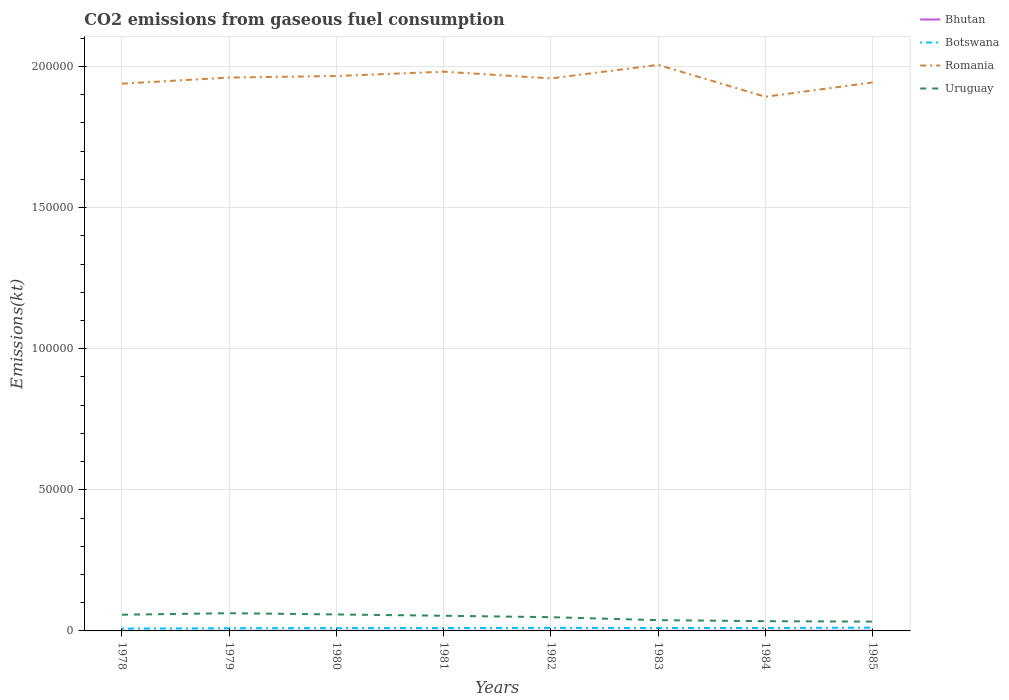How many different coloured lines are there?
Give a very brief answer. 4. Is the number of lines equal to the number of legend labels?
Your answer should be very brief. Yes. Across all years, what is the maximum amount of CO2 emitted in Uruguay?
Your response must be concise. 3296.63. What is the total amount of CO2 emitted in Romania in the graph?
Give a very brief answer. -542.72. What is the difference between the highest and the second highest amount of CO2 emitted in Botswana?
Offer a terse response. 326.36. How many lines are there?
Your answer should be very brief. 4. How many years are there in the graph?
Your answer should be compact. 8. Are the values on the major ticks of Y-axis written in scientific E-notation?
Keep it short and to the point. No. Does the graph contain grids?
Ensure brevity in your answer.  Yes. How many legend labels are there?
Offer a terse response. 4. What is the title of the graph?
Offer a terse response. CO2 emissions from gaseous fuel consumption. Does "Estonia" appear as one of the legend labels in the graph?
Provide a short and direct response. No. What is the label or title of the X-axis?
Keep it short and to the point. Years. What is the label or title of the Y-axis?
Keep it short and to the point. Emissions(kt). What is the Emissions(kt) of Bhutan in 1978?
Provide a short and direct response. 11. What is the Emissions(kt) of Botswana in 1978?
Your answer should be very brief. 832.41. What is the Emissions(kt) of Romania in 1978?
Provide a short and direct response. 1.94e+05. What is the Emissions(kt) in Uruguay in 1978?
Ensure brevity in your answer.  5742.52. What is the Emissions(kt) of Bhutan in 1979?
Offer a terse response. 22. What is the Emissions(kt) of Botswana in 1979?
Provide a short and direct response. 942.42. What is the Emissions(kt) in Romania in 1979?
Your response must be concise. 1.96e+05. What is the Emissions(kt) of Uruguay in 1979?
Your answer should be very brief. 6277.9. What is the Emissions(kt) of Bhutan in 1980?
Provide a succinct answer. 22. What is the Emissions(kt) of Botswana in 1980?
Your answer should be compact. 986.42. What is the Emissions(kt) in Romania in 1980?
Keep it short and to the point. 1.97e+05. What is the Emissions(kt) in Uruguay in 1980?
Offer a terse response. 5837.86. What is the Emissions(kt) in Bhutan in 1981?
Offer a terse response. 25.67. What is the Emissions(kt) in Botswana in 1981?
Provide a succinct answer. 1008.42. What is the Emissions(kt) in Romania in 1981?
Keep it short and to the point. 1.98e+05. What is the Emissions(kt) in Uruguay in 1981?
Your response must be concise. 5375.82. What is the Emissions(kt) in Bhutan in 1982?
Give a very brief answer. 33. What is the Emissions(kt) in Botswana in 1982?
Ensure brevity in your answer.  1100.1. What is the Emissions(kt) in Romania in 1982?
Provide a succinct answer. 1.96e+05. What is the Emissions(kt) in Uruguay in 1982?
Keep it short and to the point. 4873.44. What is the Emissions(kt) in Bhutan in 1983?
Offer a very short reply. 29.34. What is the Emissions(kt) of Botswana in 1983?
Provide a short and direct response. 1030.43. What is the Emissions(kt) of Romania in 1983?
Your response must be concise. 2.01e+05. What is the Emissions(kt) in Uruguay in 1983?
Provide a succinct answer. 3817.35. What is the Emissions(kt) in Bhutan in 1984?
Provide a short and direct response. 51.34. What is the Emissions(kt) of Botswana in 1984?
Provide a short and direct response. 1045.1. What is the Emissions(kt) of Romania in 1984?
Keep it short and to the point. 1.89e+05. What is the Emissions(kt) of Uruguay in 1984?
Provide a short and direct response. 3450.65. What is the Emissions(kt) of Bhutan in 1985?
Provide a short and direct response. 62.34. What is the Emissions(kt) of Botswana in 1985?
Give a very brief answer. 1158.77. What is the Emissions(kt) of Romania in 1985?
Provide a succinct answer. 1.94e+05. What is the Emissions(kt) in Uruguay in 1985?
Ensure brevity in your answer.  3296.63. Across all years, what is the maximum Emissions(kt) in Bhutan?
Provide a short and direct response. 62.34. Across all years, what is the maximum Emissions(kt) of Botswana?
Make the answer very short. 1158.77. Across all years, what is the maximum Emissions(kt) of Romania?
Keep it short and to the point. 2.01e+05. Across all years, what is the maximum Emissions(kt) in Uruguay?
Offer a very short reply. 6277.9. Across all years, what is the minimum Emissions(kt) in Bhutan?
Your response must be concise. 11. Across all years, what is the minimum Emissions(kt) in Botswana?
Your response must be concise. 832.41. Across all years, what is the minimum Emissions(kt) in Romania?
Provide a short and direct response. 1.89e+05. Across all years, what is the minimum Emissions(kt) of Uruguay?
Make the answer very short. 3296.63. What is the total Emissions(kt) in Bhutan in the graph?
Make the answer very short. 256.69. What is the total Emissions(kt) in Botswana in the graph?
Your answer should be compact. 8104.07. What is the total Emissions(kt) in Romania in the graph?
Your answer should be very brief. 1.56e+06. What is the total Emissions(kt) of Uruguay in the graph?
Offer a very short reply. 3.87e+04. What is the difference between the Emissions(kt) of Bhutan in 1978 and that in 1979?
Your answer should be compact. -11. What is the difference between the Emissions(kt) of Botswana in 1978 and that in 1979?
Ensure brevity in your answer.  -110.01. What is the difference between the Emissions(kt) of Romania in 1978 and that in 1979?
Your response must be concise. -2170.86. What is the difference between the Emissions(kt) in Uruguay in 1978 and that in 1979?
Ensure brevity in your answer.  -535.38. What is the difference between the Emissions(kt) in Bhutan in 1978 and that in 1980?
Ensure brevity in your answer.  -11. What is the difference between the Emissions(kt) of Botswana in 1978 and that in 1980?
Provide a short and direct response. -154.01. What is the difference between the Emissions(kt) in Romania in 1978 and that in 1980?
Offer a terse response. -2713.58. What is the difference between the Emissions(kt) in Uruguay in 1978 and that in 1980?
Ensure brevity in your answer.  -95.34. What is the difference between the Emissions(kt) of Bhutan in 1978 and that in 1981?
Offer a very short reply. -14.67. What is the difference between the Emissions(kt) of Botswana in 1978 and that in 1981?
Ensure brevity in your answer.  -176.02. What is the difference between the Emissions(kt) in Romania in 1978 and that in 1981?
Keep it short and to the point. -4250.05. What is the difference between the Emissions(kt) in Uruguay in 1978 and that in 1981?
Provide a succinct answer. 366.7. What is the difference between the Emissions(kt) in Bhutan in 1978 and that in 1982?
Your answer should be very brief. -22. What is the difference between the Emissions(kt) in Botswana in 1978 and that in 1982?
Give a very brief answer. -267.69. What is the difference between the Emissions(kt) in Romania in 1978 and that in 1982?
Offer a very short reply. -1870.17. What is the difference between the Emissions(kt) in Uruguay in 1978 and that in 1982?
Your answer should be compact. 869.08. What is the difference between the Emissions(kt) of Bhutan in 1978 and that in 1983?
Ensure brevity in your answer.  -18.34. What is the difference between the Emissions(kt) in Botswana in 1978 and that in 1983?
Make the answer very short. -198.02. What is the difference between the Emissions(kt) of Romania in 1978 and that in 1983?
Provide a succinct answer. -6659.27. What is the difference between the Emissions(kt) of Uruguay in 1978 and that in 1983?
Offer a terse response. 1925.17. What is the difference between the Emissions(kt) in Bhutan in 1978 and that in 1984?
Offer a terse response. -40.34. What is the difference between the Emissions(kt) of Botswana in 1978 and that in 1984?
Offer a terse response. -212.69. What is the difference between the Emissions(kt) of Romania in 1978 and that in 1984?
Ensure brevity in your answer.  4631.42. What is the difference between the Emissions(kt) in Uruguay in 1978 and that in 1984?
Ensure brevity in your answer.  2291.88. What is the difference between the Emissions(kt) of Bhutan in 1978 and that in 1985?
Your answer should be compact. -51.34. What is the difference between the Emissions(kt) in Botswana in 1978 and that in 1985?
Your answer should be compact. -326.36. What is the difference between the Emissions(kt) in Romania in 1978 and that in 1985?
Provide a succinct answer. -440.04. What is the difference between the Emissions(kt) of Uruguay in 1978 and that in 1985?
Provide a succinct answer. 2445.89. What is the difference between the Emissions(kt) of Botswana in 1979 and that in 1980?
Offer a terse response. -44. What is the difference between the Emissions(kt) of Romania in 1979 and that in 1980?
Your response must be concise. -542.72. What is the difference between the Emissions(kt) in Uruguay in 1979 and that in 1980?
Make the answer very short. 440.04. What is the difference between the Emissions(kt) of Bhutan in 1979 and that in 1981?
Your answer should be compact. -3.67. What is the difference between the Emissions(kt) of Botswana in 1979 and that in 1981?
Make the answer very short. -66.01. What is the difference between the Emissions(kt) in Romania in 1979 and that in 1981?
Ensure brevity in your answer.  -2079.19. What is the difference between the Emissions(kt) of Uruguay in 1979 and that in 1981?
Your answer should be very brief. 902.08. What is the difference between the Emissions(kt) in Bhutan in 1979 and that in 1982?
Provide a short and direct response. -11. What is the difference between the Emissions(kt) of Botswana in 1979 and that in 1982?
Offer a very short reply. -157.68. What is the difference between the Emissions(kt) in Romania in 1979 and that in 1982?
Keep it short and to the point. 300.69. What is the difference between the Emissions(kt) in Uruguay in 1979 and that in 1982?
Make the answer very short. 1404.46. What is the difference between the Emissions(kt) in Bhutan in 1979 and that in 1983?
Ensure brevity in your answer.  -7.33. What is the difference between the Emissions(kt) of Botswana in 1979 and that in 1983?
Provide a short and direct response. -88.01. What is the difference between the Emissions(kt) of Romania in 1979 and that in 1983?
Make the answer very short. -4488.41. What is the difference between the Emissions(kt) in Uruguay in 1979 and that in 1983?
Keep it short and to the point. 2460.56. What is the difference between the Emissions(kt) in Bhutan in 1979 and that in 1984?
Offer a very short reply. -29.34. What is the difference between the Emissions(kt) of Botswana in 1979 and that in 1984?
Your answer should be compact. -102.68. What is the difference between the Emissions(kt) in Romania in 1979 and that in 1984?
Keep it short and to the point. 6802.28. What is the difference between the Emissions(kt) in Uruguay in 1979 and that in 1984?
Provide a succinct answer. 2827.26. What is the difference between the Emissions(kt) of Bhutan in 1979 and that in 1985?
Provide a short and direct response. -40.34. What is the difference between the Emissions(kt) of Botswana in 1979 and that in 1985?
Give a very brief answer. -216.35. What is the difference between the Emissions(kt) in Romania in 1979 and that in 1985?
Provide a succinct answer. 1730.82. What is the difference between the Emissions(kt) of Uruguay in 1979 and that in 1985?
Ensure brevity in your answer.  2981.27. What is the difference between the Emissions(kt) in Bhutan in 1980 and that in 1981?
Your answer should be compact. -3.67. What is the difference between the Emissions(kt) in Botswana in 1980 and that in 1981?
Offer a terse response. -22. What is the difference between the Emissions(kt) of Romania in 1980 and that in 1981?
Your answer should be compact. -1536.47. What is the difference between the Emissions(kt) of Uruguay in 1980 and that in 1981?
Offer a terse response. 462.04. What is the difference between the Emissions(kt) in Bhutan in 1980 and that in 1982?
Your response must be concise. -11. What is the difference between the Emissions(kt) in Botswana in 1980 and that in 1982?
Your answer should be compact. -113.68. What is the difference between the Emissions(kt) of Romania in 1980 and that in 1982?
Your answer should be compact. 843.41. What is the difference between the Emissions(kt) of Uruguay in 1980 and that in 1982?
Provide a succinct answer. 964.42. What is the difference between the Emissions(kt) in Bhutan in 1980 and that in 1983?
Your answer should be compact. -7.33. What is the difference between the Emissions(kt) of Botswana in 1980 and that in 1983?
Make the answer very short. -44. What is the difference between the Emissions(kt) in Romania in 1980 and that in 1983?
Your answer should be very brief. -3945.69. What is the difference between the Emissions(kt) of Uruguay in 1980 and that in 1983?
Provide a succinct answer. 2020.52. What is the difference between the Emissions(kt) in Bhutan in 1980 and that in 1984?
Give a very brief answer. -29.34. What is the difference between the Emissions(kt) of Botswana in 1980 and that in 1984?
Your response must be concise. -58.67. What is the difference between the Emissions(kt) of Romania in 1980 and that in 1984?
Offer a very short reply. 7345. What is the difference between the Emissions(kt) of Uruguay in 1980 and that in 1984?
Keep it short and to the point. 2387.22. What is the difference between the Emissions(kt) in Bhutan in 1980 and that in 1985?
Give a very brief answer. -40.34. What is the difference between the Emissions(kt) in Botswana in 1980 and that in 1985?
Provide a short and direct response. -172.35. What is the difference between the Emissions(kt) in Romania in 1980 and that in 1985?
Ensure brevity in your answer.  2273.54. What is the difference between the Emissions(kt) of Uruguay in 1980 and that in 1985?
Give a very brief answer. 2541.23. What is the difference between the Emissions(kt) of Bhutan in 1981 and that in 1982?
Keep it short and to the point. -7.33. What is the difference between the Emissions(kt) of Botswana in 1981 and that in 1982?
Your answer should be very brief. -91.67. What is the difference between the Emissions(kt) of Romania in 1981 and that in 1982?
Provide a short and direct response. 2379.88. What is the difference between the Emissions(kt) in Uruguay in 1981 and that in 1982?
Your answer should be very brief. 502.38. What is the difference between the Emissions(kt) of Bhutan in 1981 and that in 1983?
Ensure brevity in your answer.  -3.67. What is the difference between the Emissions(kt) in Botswana in 1981 and that in 1983?
Offer a very short reply. -22. What is the difference between the Emissions(kt) of Romania in 1981 and that in 1983?
Make the answer very short. -2409.22. What is the difference between the Emissions(kt) of Uruguay in 1981 and that in 1983?
Provide a succinct answer. 1558.47. What is the difference between the Emissions(kt) of Bhutan in 1981 and that in 1984?
Offer a terse response. -25.67. What is the difference between the Emissions(kt) of Botswana in 1981 and that in 1984?
Provide a succinct answer. -36.67. What is the difference between the Emissions(kt) of Romania in 1981 and that in 1984?
Provide a succinct answer. 8881.47. What is the difference between the Emissions(kt) in Uruguay in 1981 and that in 1984?
Provide a short and direct response. 1925.17. What is the difference between the Emissions(kt) in Bhutan in 1981 and that in 1985?
Offer a terse response. -36.67. What is the difference between the Emissions(kt) in Botswana in 1981 and that in 1985?
Offer a very short reply. -150.35. What is the difference between the Emissions(kt) of Romania in 1981 and that in 1985?
Your answer should be compact. 3810.01. What is the difference between the Emissions(kt) in Uruguay in 1981 and that in 1985?
Give a very brief answer. 2079.19. What is the difference between the Emissions(kt) in Bhutan in 1982 and that in 1983?
Your answer should be compact. 3.67. What is the difference between the Emissions(kt) of Botswana in 1982 and that in 1983?
Your response must be concise. 69.67. What is the difference between the Emissions(kt) of Romania in 1982 and that in 1983?
Ensure brevity in your answer.  -4789.1. What is the difference between the Emissions(kt) in Uruguay in 1982 and that in 1983?
Give a very brief answer. 1056.1. What is the difference between the Emissions(kt) of Bhutan in 1982 and that in 1984?
Make the answer very short. -18.34. What is the difference between the Emissions(kt) of Botswana in 1982 and that in 1984?
Your answer should be very brief. 55.01. What is the difference between the Emissions(kt) in Romania in 1982 and that in 1984?
Your answer should be very brief. 6501.59. What is the difference between the Emissions(kt) of Uruguay in 1982 and that in 1984?
Offer a terse response. 1422.8. What is the difference between the Emissions(kt) in Bhutan in 1982 and that in 1985?
Make the answer very short. -29.34. What is the difference between the Emissions(kt) in Botswana in 1982 and that in 1985?
Provide a succinct answer. -58.67. What is the difference between the Emissions(kt) of Romania in 1982 and that in 1985?
Provide a succinct answer. 1430.13. What is the difference between the Emissions(kt) in Uruguay in 1982 and that in 1985?
Your answer should be very brief. 1576.81. What is the difference between the Emissions(kt) of Bhutan in 1983 and that in 1984?
Provide a short and direct response. -22. What is the difference between the Emissions(kt) of Botswana in 1983 and that in 1984?
Offer a very short reply. -14.67. What is the difference between the Emissions(kt) of Romania in 1983 and that in 1984?
Your response must be concise. 1.13e+04. What is the difference between the Emissions(kt) of Uruguay in 1983 and that in 1984?
Provide a short and direct response. 366.7. What is the difference between the Emissions(kt) in Bhutan in 1983 and that in 1985?
Provide a succinct answer. -33. What is the difference between the Emissions(kt) of Botswana in 1983 and that in 1985?
Offer a very short reply. -128.34. What is the difference between the Emissions(kt) in Romania in 1983 and that in 1985?
Keep it short and to the point. 6219.23. What is the difference between the Emissions(kt) in Uruguay in 1983 and that in 1985?
Provide a short and direct response. 520.71. What is the difference between the Emissions(kt) of Bhutan in 1984 and that in 1985?
Keep it short and to the point. -11. What is the difference between the Emissions(kt) in Botswana in 1984 and that in 1985?
Your answer should be compact. -113.68. What is the difference between the Emissions(kt) of Romania in 1984 and that in 1985?
Keep it short and to the point. -5071.46. What is the difference between the Emissions(kt) in Uruguay in 1984 and that in 1985?
Keep it short and to the point. 154.01. What is the difference between the Emissions(kt) of Bhutan in 1978 and the Emissions(kt) of Botswana in 1979?
Provide a short and direct response. -931.42. What is the difference between the Emissions(kt) in Bhutan in 1978 and the Emissions(kt) in Romania in 1979?
Give a very brief answer. -1.96e+05. What is the difference between the Emissions(kt) of Bhutan in 1978 and the Emissions(kt) of Uruguay in 1979?
Make the answer very short. -6266.9. What is the difference between the Emissions(kt) in Botswana in 1978 and the Emissions(kt) in Romania in 1979?
Ensure brevity in your answer.  -1.95e+05. What is the difference between the Emissions(kt) of Botswana in 1978 and the Emissions(kt) of Uruguay in 1979?
Provide a succinct answer. -5445.49. What is the difference between the Emissions(kt) in Romania in 1978 and the Emissions(kt) in Uruguay in 1979?
Offer a terse response. 1.88e+05. What is the difference between the Emissions(kt) in Bhutan in 1978 and the Emissions(kt) in Botswana in 1980?
Provide a succinct answer. -975.42. What is the difference between the Emissions(kt) in Bhutan in 1978 and the Emissions(kt) in Romania in 1980?
Offer a very short reply. -1.97e+05. What is the difference between the Emissions(kt) of Bhutan in 1978 and the Emissions(kt) of Uruguay in 1980?
Keep it short and to the point. -5826.86. What is the difference between the Emissions(kt) of Botswana in 1978 and the Emissions(kt) of Romania in 1980?
Your answer should be compact. -1.96e+05. What is the difference between the Emissions(kt) of Botswana in 1978 and the Emissions(kt) of Uruguay in 1980?
Your answer should be compact. -5005.45. What is the difference between the Emissions(kt) of Romania in 1978 and the Emissions(kt) of Uruguay in 1980?
Keep it short and to the point. 1.88e+05. What is the difference between the Emissions(kt) of Bhutan in 1978 and the Emissions(kt) of Botswana in 1981?
Offer a terse response. -997.42. What is the difference between the Emissions(kt) of Bhutan in 1978 and the Emissions(kt) of Romania in 1981?
Your answer should be very brief. -1.98e+05. What is the difference between the Emissions(kt) of Bhutan in 1978 and the Emissions(kt) of Uruguay in 1981?
Your answer should be compact. -5364.82. What is the difference between the Emissions(kt) in Botswana in 1978 and the Emissions(kt) in Romania in 1981?
Provide a short and direct response. -1.97e+05. What is the difference between the Emissions(kt) of Botswana in 1978 and the Emissions(kt) of Uruguay in 1981?
Offer a very short reply. -4543.41. What is the difference between the Emissions(kt) in Romania in 1978 and the Emissions(kt) in Uruguay in 1981?
Your answer should be very brief. 1.89e+05. What is the difference between the Emissions(kt) in Bhutan in 1978 and the Emissions(kt) in Botswana in 1982?
Your response must be concise. -1089.1. What is the difference between the Emissions(kt) in Bhutan in 1978 and the Emissions(kt) in Romania in 1982?
Provide a short and direct response. -1.96e+05. What is the difference between the Emissions(kt) of Bhutan in 1978 and the Emissions(kt) of Uruguay in 1982?
Your answer should be compact. -4862.44. What is the difference between the Emissions(kt) of Botswana in 1978 and the Emissions(kt) of Romania in 1982?
Provide a short and direct response. -1.95e+05. What is the difference between the Emissions(kt) in Botswana in 1978 and the Emissions(kt) in Uruguay in 1982?
Keep it short and to the point. -4041.03. What is the difference between the Emissions(kt) of Romania in 1978 and the Emissions(kt) of Uruguay in 1982?
Give a very brief answer. 1.89e+05. What is the difference between the Emissions(kt) in Bhutan in 1978 and the Emissions(kt) in Botswana in 1983?
Offer a terse response. -1019.43. What is the difference between the Emissions(kt) of Bhutan in 1978 and the Emissions(kt) of Romania in 1983?
Your response must be concise. -2.01e+05. What is the difference between the Emissions(kt) in Bhutan in 1978 and the Emissions(kt) in Uruguay in 1983?
Your response must be concise. -3806.35. What is the difference between the Emissions(kt) in Botswana in 1978 and the Emissions(kt) in Romania in 1983?
Your answer should be compact. -2.00e+05. What is the difference between the Emissions(kt) in Botswana in 1978 and the Emissions(kt) in Uruguay in 1983?
Provide a succinct answer. -2984.94. What is the difference between the Emissions(kt) of Romania in 1978 and the Emissions(kt) of Uruguay in 1983?
Your answer should be very brief. 1.90e+05. What is the difference between the Emissions(kt) of Bhutan in 1978 and the Emissions(kt) of Botswana in 1984?
Your answer should be compact. -1034.09. What is the difference between the Emissions(kt) of Bhutan in 1978 and the Emissions(kt) of Romania in 1984?
Offer a terse response. -1.89e+05. What is the difference between the Emissions(kt) in Bhutan in 1978 and the Emissions(kt) in Uruguay in 1984?
Your answer should be very brief. -3439.65. What is the difference between the Emissions(kt) in Botswana in 1978 and the Emissions(kt) in Romania in 1984?
Make the answer very short. -1.88e+05. What is the difference between the Emissions(kt) in Botswana in 1978 and the Emissions(kt) in Uruguay in 1984?
Provide a succinct answer. -2618.24. What is the difference between the Emissions(kt) of Romania in 1978 and the Emissions(kt) of Uruguay in 1984?
Provide a short and direct response. 1.90e+05. What is the difference between the Emissions(kt) in Bhutan in 1978 and the Emissions(kt) in Botswana in 1985?
Give a very brief answer. -1147.77. What is the difference between the Emissions(kt) of Bhutan in 1978 and the Emissions(kt) of Romania in 1985?
Provide a short and direct response. -1.94e+05. What is the difference between the Emissions(kt) in Bhutan in 1978 and the Emissions(kt) in Uruguay in 1985?
Ensure brevity in your answer.  -3285.63. What is the difference between the Emissions(kt) of Botswana in 1978 and the Emissions(kt) of Romania in 1985?
Offer a very short reply. -1.94e+05. What is the difference between the Emissions(kt) in Botswana in 1978 and the Emissions(kt) in Uruguay in 1985?
Offer a terse response. -2464.22. What is the difference between the Emissions(kt) in Romania in 1978 and the Emissions(kt) in Uruguay in 1985?
Offer a terse response. 1.91e+05. What is the difference between the Emissions(kt) in Bhutan in 1979 and the Emissions(kt) in Botswana in 1980?
Your response must be concise. -964.42. What is the difference between the Emissions(kt) of Bhutan in 1979 and the Emissions(kt) of Romania in 1980?
Your response must be concise. -1.97e+05. What is the difference between the Emissions(kt) of Bhutan in 1979 and the Emissions(kt) of Uruguay in 1980?
Your answer should be compact. -5815.86. What is the difference between the Emissions(kt) in Botswana in 1979 and the Emissions(kt) in Romania in 1980?
Your response must be concise. -1.96e+05. What is the difference between the Emissions(kt) of Botswana in 1979 and the Emissions(kt) of Uruguay in 1980?
Your answer should be compact. -4895.44. What is the difference between the Emissions(kt) in Romania in 1979 and the Emissions(kt) in Uruguay in 1980?
Your answer should be compact. 1.90e+05. What is the difference between the Emissions(kt) in Bhutan in 1979 and the Emissions(kt) in Botswana in 1981?
Offer a very short reply. -986.42. What is the difference between the Emissions(kt) of Bhutan in 1979 and the Emissions(kt) of Romania in 1981?
Give a very brief answer. -1.98e+05. What is the difference between the Emissions(kt) of Bhutan in 1979 and the Emissions(kt) of Uruguay in 1981?
Your response must be concise. -5353.82. What is the difference between the Emissions(kt) in Botswana in 1979 and the Emissions(kt) in Romania in 1981?
Make the answer very short. -1.97e+05. What is the difference between the Emissions(kt) of Botswana in 1979 and the Emissions(kt) of Uruguay in 1981?
Your response must be concise. -4433.4. What is the difference between the Emissions(kt) in Romania in 1979 and the Emissions(kt) in Uruguay in 1981?
Offer a very short reply. 1.91e+05. What is the difference between the Emissions(kt) of Bhutan in 1979 and the Emissions(kt) of Botswana in 1982?
Keep it short and to the point. -1078.1. What is the difference between the Emissions(kt) in Bhutan in 1979 and the Emissions(kt) in Romania in 1982?
Keep it short and to the point. -1.96e+05. What is the difference between the Emissions(kt) in Bhutan in 1979 and the Emissions(kt) in Uruguay in 1982?
Provide a succinct answer. -4851.44. What is the difference between the Emissions(kt) of Botswana in 1979 and the Emissions(kt) of Romania in 1982?
Offer a terse response. -1.95e+05. What is the difference between the Emissions(kt) in Botswana in 1979 and the Emissions(kt) in Uruguay in 1982?
Your response must be concise. -3931.02. What is the difference between the Emissions(kt) of Romania in 1979 and the Emissions(kt) of Uruguay in 1982?
Keep it short and to the point. 1.91e+05. What is the difference between the Emissions(kt) of Bhutan in 1979 and the Emissions(kt) of Botswana in 1983?
Ensure brevity in your answer.  -1008.42. What is the difference between the Emissions(kt) of Bhutan in 1979 and the Emissions(kt) of Romania in 1983?
Keep it short and to the point. -2.01e+05. What is the difference between the Emissions(kt) of Bhutan in 1979 and the Emissions(kt) of Uruguay in 1983?
Your answer should be very brief. -3795.34. What is the difference between the Emissions(kt) in Botswana in 1979 and the Emissions(kt) in Romania in 1983?
Keep it short and to the point. -2.00e+05. What is the difference between the Emissions(kt) in Botswana in 1979 and the Emissions(kt) in Uruguay in 1983?
Offer a very short reply. -2874.93. What is the difference between the Emissions(kt) of Romania in 1979 and the Emissions(kt) of Uruguay in 1983?
Your response must be concise. 1.92e+05. What is the difference between the Emissions(kt) in Bhutan in 1979 and the Emissions(kt) in Botswana in 1984?
Offer a terse response. -1023.09. What is the difference between the Emissions(kt) of Bhutan in 1979 and the Emissions(kt) of Romania in 1984?
Keep it short and to the point. -1.89e+05. What is the difference between the Emissions(kt) in Bhutan in 1979 and the Emissions(kt) in Uruguay in 1984?
Your answer should be very brief. -3428.64. What is the difference between the Emissions(kt) in Botswana in 1979 and the Emissions(kt) in Romania in 1984?
Provide a short and direct response. -1.88e+05. What is the difference between the Emissions(kt) of Botswana in 1979 and the Emissions(kt) of Uruguay in 1984?
Your answer should be compact. -2508.23. What is the difference between the Emissions(kt) in Romania in 1979 and the Emissions(kt) in Uruguay in 1984?
Make the answer very short. 1.93e+05. What is the difference between the Emissions(kt) of Bhutan in 1979 and the Emissions(kt) of Botswana in 1985?
Ensure brevity in your answer.  -1136.77. What is the difference between the Emissions(kt) of Bhutan in 1979 and the Emissions(kt) of Romania in 1985?
Make the answer very short. -1.94e+05. What is the difference between the Emissions(kt) in Bhutan in 1979 and the Emissions(kt) in Uruguay in 1985?
Give a very brief answer. -3274.63. What is the difference between the Emissions(kt) of Botswana in 1979 and the Emissions(kt) of Romania in 1985?
Keep it short and to the point. -1.93e+05. What is the difference between the Emissions(kt) in Botswana in 1979 and the Emissions(kt) in Uruguay in 1985?
Ensure brevity in your answer.  -2354.21. What is the difference between the Emissions(kt) in Romania in 1979 and the Emissions(kt) in Uruguay in 1985?
Keep it short and to the point. 1.93e+05. What is the difference between the Emissions(kt) of Bhutan in 1980 and the Emissions(kt) of Botswana in 1981?
Make the answer very short. -986.42. What is the difference between the Emissions(kt) in Bhutan in 1980 and the Emissions(kt) in Romania in 1981?
Offer a terse response. -1.98e+05. What is the difference between the Emissions(kt) of Bhutan in 1980 and the Emissions(kt) of Uruguay in 1981?
Provide a short and direct response. -5353.82. What is the difference between the Emissions(kt) in Botswana in 1980 and the Emissions(kt) in Romania in 1981?
Ensure brevity in your answer.  -1.97e+05. What is the difference between the Emissions(kt) of Botswana in 1980 and the Emissions(kt) of Uruguay in 1981?
Make the answer very short. -4389.4. What is the difference between the Emissions(kt) of Romania in 1980 and the Emissions(kt) of Uruguay in 1981?
Give a very brief answer. 1.91e+05. What is the difference between the Emissions(kt) in Bhutan in 1980 and the Emissions(kt) in Botswana in 1982?
Your answer should be compact. -1078.1. What is the difference between the Emissions(kt) in Bhutan in 1980 and the Emissions(kt) in Romania in 1982?
Offer a terse response. -1.96e+05. What is the difference between the Emissions(kt) in Bhutan in 1980 and the Emissions(kt) in Uruguay in 1982?
Your response must be concise. -4851.44. What is the difference between the Emissions(kt) in Botswana in 1980 and the Emissions(kt) in Romania in 1982?
Provide a succinct answer. -1.95e+05. What is the difference between the Emissions(kt) in Botswana in 1980 and the Emissions(kt) in Uruguay in 1982?
Your answer should be very brief. -3887.02. What is the difference between the Emissions(kt) of Romania in 1980 and the Emissions(kt) of Uruguay in 1982?
Your answer should be very brief. 1.92e+05. What is the difference between the Emissions(kt) of Bhutan in 1980 and the Emissions(kt) of Botswana in 1983?
Offer a very short reply. -1008.42. What is the difference between the Emissions(kt) of Bhutan in 1980 and the Emissions(kt) of Romania in 1983?
Offer a very short reply. -2.01e+05. What is the difference between the Emissions(kt) of Bhutan in 1980 and the Emissions(kt) of Uruguay in 1983?
Your answer should be compact. -3795.34. What is the difference between the Emissions(kt) of Botswana in 1980 and the Emissions(kt) of Romania in 1983?
Offer a very short reply. -2.00e+05. What is the difference between the Emissions(kt) of Botswana in 1980 and the Emissions(kt) of Uruguay in 1983?
Provide a succinct answer. -2830.92. What is the difference between the Emissions(kt) in Romania in 1980 and the Emissions(kt) in Uruguay in 1983?
Your response must be concise. 1.93e+05. What is the difference between the Emissions(kt) of Bhutan in 1980 and the Emissions(kt) of Botswana in 1984?
Provide a short and direct response. -1023.09. What is the difference between the Emissions(kt) of Bhutan in 1980 and the Emissions(kt) of Romania in 1984?
Ensure brevity in your answer.  -1.89e+05. What is the difference between the Emissions(kt) in Bhutan in 1980 and the Emissions(kt) in Uruguay in 1984?
Offer a very short reply. -3428.64. What is the difference between the Emissions(kt) of Botswana in 1980 and the Emissions(kt) of Romania in 1984?
Offer a terse response. -1.88e+05. What is the difference between the Emissions(kt) of Botswana in 1980 and the Emissions(kt) of Uruguay in 1984?
Keep it short and to the point. -2464.22. What is the difference between the Emissions(kt) in Romania in 1980 and the Emissions(kt) in Uruguay in 1984?
Provide a succinct answer. 1.93e+05. What is the difference between the Emissions(kt) of Bhutan in 1980 and the Emissions(kt) of Botswana in 1985?
Provide a short and direct response. -1136.77. What is the difference between the Emissions(kt) of Bhutan in 1980 and the Emissions(kt) of Romania in 1985?
Ensure brevity in your answer.  -1.94e+05. What is the difference between the Emissions(kt) in Bhutan in 1980 and the Emissions(kt) in Uruguay in 1985?
Your answer should be very brief. -3274.63. What is the difference between the Emissions(kt) of Botswana in 1980 and the Emissions(kt) of Romania in 1985?
Provide a succinct answer. -1.93e+05. What is the difference between the Emissions(kt) of Botswana in 1980 and the Emissions(kt) of Uruguay in 1985?
Your answer should be compact. -2310.21. What is the difference between the Emissions(kt) of Romania in 1980 and the Emissions(kt) of Uruguay in 1985?
Keep it short and to the point. 1.93e+05. What is the difference between the Emissions(kt) in Bhutan in 1981 and the Emissions(kt) in Botswana in 1982?
Your response must be concise. -1074.43. What is the difference between the Emissions(kt) of Bhutan in 1981 and the Emissions(kt) of Romania in 1982?
Your response must be concise. -1.96e+05. What is the difference between the Emissions(kt) in Bhutan in 1981 and the Emissions(kt) in Uruguay in 1982?
Ensure brevity in your answer.  -4847.77. What is the difference between the Emissions(kt) in Botswana in 1981 and the Emissions(kt) in Romania in 1982?
Keep it short and to the point. -1.95e+05. What is the difference between the Emissions(kt) of Botswana in 1981 and the Emissions(kt) of Uruguay in 1982?
Provide a short and direct response. -3865.02. What is the difference between the Emissions(kt) in Romania in 1981 and the Emissions(kt) in Uruguay in 1982?
Provide a short and direct response. 1.93e+05. What is the difference between the Emissions(kt) in Bhutan in 1981 and the Emissions(kt) in Botswana in 1983?
Make the answer very short. -1004.76. What is the difference between the Emissions(kt) of Bhutan in 1981 and the Emissions(kt) of Romania in 1983?
Keep it short and to the point. -2.01e+05. What is the difference between the Emissions(kt) of Bhutan in 1981 and the Emissions(kt) of Uruguay in 1983?
Offer a terse response. -3791.68. What is the difference between the Emissions(kt) of Botswana in 1981 and the Emissions(kt) of Romania in 1983?
Keep it short and to the point. -2.00e+05. What is the difference between the Emissions(kt) of Botswana in 1981 and the Emissions(kt) of Uruguay in 1983?
Ensure brevity in your answer.  -2808.92. What is the difference between the Emissions(kt) in Romania in 1981 and the Emissions(kt) in Uruguay in 1983?
Provide a succinct answer. 1.94e+05. What is the difference between the Emissions(kt) in Bhutan in 1981 and the Emissions(kt) in Botswana in 1984?
Make the answer very short. -1019.43. What is the difference between the Emissions(kt) of Bhutan in 1981 and the Emissions(kt) of Romania in 1984?
Keep it short and to the point. -1.89e+05. What is the difference between the Emissions(kt) in Bhutan in 1981 and the Emissions(kt) in Uruguay in 1984?
Give a very brief answer. -3424.98. What is the difference between the Emissions(kt) of Botswana in 1981 and the Emissions(kt) of Romania in 1984?
Give a very brief answer. -1.88e+05. What is the difference between the Emissions(kt) of Botswana in 1981 and the Emissions(kt) of Uruguay in 1984?
Offer a very short reply. -2442.22. What is the difference between the Emissions(kt) of Romania in 1981 and the Emissions(kt) of Uruguay in 1984?
Ensure brevity in your answer.  1.95e+05. What is the difference between the Emissions(kt) in Bhutan in 1981 and the Emissions(kt) in Botswana in 1985?
Offer a very short reply. -1133.1. What is the difference between the Emissions(kt) in Bhutan in 1981 and the Emissions(kt) in Romania in 1985?
Give a very brief answer. -1.94e+05. What is the difference between the Emissions(kt) of Bhutan in 1981 and the Emissions(kt) of Uruguay in 1985?
Your response must be concise. -3270.96. What is the difference between the Emissions(kt) of Botswana in 1981 and the Emissions(kt) of Romania in 1985?
Make the answer very short. -1.93e+05. What is the difference between the Emissions(kt) in Botswana in 1981 and the Emissions(kt) in Uruguay in 1985?
Provide a succinct answer. -2288.21. What is the difference between the Emissions(kt) in Romania in 1981 and the Emissions(kt) in Uruguay in 1985?
Provide a succinct answer. 1.95e+05. What is the difference between the Emissions(kt) in Bhutan in 1982 and the Emissions(kt) in Botswana in 1983?
Keep it short and to the point. -997.42. What is the difference between the Emissions(kt) of Bhutan in 1982 and the Emissions(kt) of Romania in 1983?
Keep it short and to the point. -2.01e+05. What is the difference between the Emissions(kt) of Bhutan in 1982 and the Emissions(kt) of Uruguay in 1983?
Offer a terse response. -3784.34. What is the difference between the Emissions(kt) in Botswana in 1982 and the Emissions(kt) in Romania in 1983?
Offer a very short reply. -1.99e+05. What is the difference between the Emissions(kt) in Botswana in 1982 and the Emissions(kt) in Uruguay in 1983?
Provide a short and direct response. -2717.25. What is the difference between the Emissions(kt) in Romania in 1982 and the Emissions(kt) in Uruguay in 1983?
Offer a very short reply. 1.92e+05. What is the difference between the Emissions(kt) of Bhutan in 1982 and the Emissions(kt) of Botswana in 1984?
Your response must be concise. -1012.09. What is the difference between the Emissions(kt) of Bhutan in 1982 and the Emissions(kt) of Romania in 1984?
Your answer should be very brief. -1.89e+05. What is the difference between the Emissions(kt) in Bhutan in 1982 and the Emissions(kt) in Uruguay in 1984?
Make the answer very short. -3417.64. What is the difference between the Emissions(kt) of Botswana in 1982 and the Emissions(kt) of Romania in 1984?
Provide a succinct answer. -1.88e+05. What is the difference between the Emissions(kt) of Botswana in 1982 and the Emissions(kt) of Uruguay in 1984?
Offer a very short reply. -2350.55. What is the difference between the Emissions(kt) in Romania in 1982 and the Emissions(kt) in Uruguay in 1984?
Your answer should be very brief. 1.92e+05. What is the difference between the Emissions(kt) in Bhutan in 1982 and the Emissions(kt) in Botswana in 1985?
Your answer should be very brief. -1125.77. What is the difference between the Emissions(kt) in Bhutan in 1982 and the Emissions(kt) in Romania in 1985?
Give a very brief answer. -1.94e+05. What is the difference between the Emissions(kt) in Bhutan in 1982 and the Emissions(kt) in Uruguay in 1985?
Keep it short and to the point. -3263.63. What is the difference between the Emissions(kt) in Botswana in 1982 and the Emissions(kt) in Romania in 1985?
Your response must be concise. -1.93e+05. What is the difference between the Emissions(kt) in Botswana in 1982 and the Emissions(kt) in Uruguay in 1985?
Make the answer very short. -2196.53. What is the difference between the Emissions(kt) in Romania in 1982 and the Emissions(kt) in Uruguay in 1985?
Provide a short and direct response. 1.92e+05. What is the difference between the Emissions(kt) in Bhutan in 1983 and the Emissions(kt) in Botswana in 1984?
Your response must be concise. -1015.76. What is the difference between the Emissions(kt) in Bhutan in 1983 and the Emissions(kt) in Romania in 1984?
Offer a terse response. -1.89e+05. What is the difference between the Emissions(kt) in Bhutan in 1983 and the Emissions(kt) in Uruguay in 1984?
Give a very brief answer. -3421.31. What is the difference between the Emissions(kt) in Botswana in 1983 and the Emissions(kt) in Romania in 1984?
Your response must be concise. -1.88e+05. What is the difference between the Emissions(kt) of Botswana in 1983 and the Emissions(kt) of Uruguay in 1984?
Your answer should be very brief. -2420.22. What is the difference between the Emissions(kt) of Romania in 1983 and the Emissions(kt) of Uruguay in 1984?
Provide a short and direct response. 1.97e+05. What is the difference between the Emissions(kt) of Bhutan in 1983 and the Emissions(kt) of Botswana in 1985?
Make the answer very short. -1129.44. What is the difference between the Emissions(kt) of Bhutan in 1983 and the Emissions(kt) of Romania in 1985?
Your answer should be compact. -1.94e+05. What is the difference between the Emissions(kt) of Bhutan in 1983 and the Emissions(kt) of Uruguay in 1985?
Your response must be concise. -3267.3. What is the difference between the Emissions(kt) in Botswana in 1983 and the Emissions(kt) in Romania in 1985?
Give a very brief answer. -1.93e+05. What is the difference between the Emissions(kt) in Botswana in 1983 and the Emissions(kt) in Uruguay in 1985?
Ensure brevity in your answer.  -2266.21. What is the difference between the Emissions(kt) of Romania in 1983 and the Emissions(kt) of Uruguay in 1985?
Your answer should be compact. 1.97e+05. What is the difference between the Emissions(kt) of Bhutan in 1984 and the Emissions(kt) of Botswana in 1985?
Make the answer very short. -1107.43. What is the difference between the Emissions(kt) of Bhutan in 1984 and the Emissions(kt) of Romania in 1985?
Provide a short and direct response. -1.94e+05. What is the difference between the Emissions(kt) of Bhutan in 1984 and the Emissions(kt) of Uruguay in 1985?
Provide a succinct answer. -3245.3. What is the difference between the Emissions(kt) of Botswana in 1984 and the Emissions(kt) of Romania in 1985?
Make the answer very short. -1.93e+05. What is the difference between the Emissions(kt) in Botswana in 1984 and the Emissions(kt) in Uruguay in 1985?
Offer a terse response. -2251.54. What is the difference between the Emissions(kt) in Romania in 1984 and the Emissions(kt) in Uruguay in 1985?
Give a very brief answer. 1.86e+05. What is the average Emissions(kt) of Bhutan per year?
Offer a very short reply. 32.09. What is the average Emissions(kt) of Botswana per year?
Give a very brief answer. 1013.01. What is the average Emissions(kt) of Romania per year?
Provide a succinct answer. 1.96e+05. What is the average Emissions(kt) of Uruguay per year?
Keep it short and to the point. 4834.02. In the year 1978, what is the difference between the Emissions(kt) in Bhutan and Emissions(kt) in Botswana?
Your answer should be very brief. -821.41. In the year 1978, what is the difference between the Emissions(kt) of Bhutan and Emissions(kt) of Romania?
Provide a short and direct response. -1.94e+05. In the year 1978, what is the difference between the Emissions(kt) of Bhutan and Emissions(kt) of Uruguay?
Make the answer very short. -5731.52. In the year 1978, what is the difference between the Emissions(kt) in Botswana and Emissions(kt) in Romania?
Ensure brevity in your answer.  -1.93e+05. In the year 1978, what is the difference between the Emissions(kt) in Botswana and Emissions(kt) in Uruguay?
Offer a terse response. -4910.11. In the year 1978, what is the difference between the Emissions(kt) in Romania and Emissions(kt) in Uruguay?
Provide a short and direct response. 1.88e+05. In the year 1979, what is the difference between the Emissions(kt) in Bhutan and Emissions(kt) in Botswana?
Make the answer very short. -920.42. In the year 1979, what is the difference between the Emissions(kt) of Bhutan and Emissions(kt) of Romania?
Give a very brief answer. -1.96e+05. In the year 1979, what is the difference between the Emissions(kt) in Bhutan and Emissions(kt) in Uruguay?
Provide a short and direct response. -6255.9. In the year 1979, what is the difference between the Emissions(kt) in Botswana and Emissions(kt) in Romania?
Provide a short and direct response. -1.95e+05. In the year 1979, what is the difference between the Emissions(kt) in Botswana and Emissions(kt) in Uruguay?
Your answer should be very brief. -5335.48. In the year 1979, what is the difference between the Emissions(kt) in Romania and Emissions(kt) in Uruguay?
Make the answer very short. 1.90e+05. In the year 1980, what is the difference between the Emissions(kt) of Bhutan and Emissions(kt) of Botswana?
Give a very brief answer. -964.42. In the year 1980, what is the difference between the Emissions(kt) of Bhutan and Emissions(kt) of Romania?
Your answer should be compact. -1.97e+05. In the year 1980, what is the difference between the Emissions(kt) of Bhutan and Emissions(kt) of Uruguay?
Your answer should be very brief. -5815.86. In the year 1980, what is the difference between the Emissions(kt) of Botswana and Emissions(kt) of Romania?
Offer a terse response. -1.96e+05. In the year 1980, what is the difference between the Emissions(kt) of Botswana and Emissions(kt) of Uruguay?
Provide a succinct answer. -4851.44. In the year 1980, what is the difference between the Emissions(kt) in Romania and Emissions(kt) in Uruguay?
Provide a short and direct response. 1.91e+05. In the year 1981, what is the difference between the Emissions(kt) of Bhutan and Emissions(kt) of Botswana?
Your answer should be very brief. -982.76. In the year 1981, what is the difference between the Emissions(kt) in Bhutan and Emissions(kt) in Romania?
Your answer should be very brief. -1.98e+05. In the year 1981, what is the difference between the Emissions(kt) in Bhutan and Emissions(kt) in Uruguay?
Keep it short and to the point. -5350.15. In the year 1981, what is the difference between the Emissions(kt) in Botswana and Emissions(kt) in Romania?
Keep it short and to the point. -1.97e+05. In the year 1981, what is the difference between the Emissions(kt) of Botswana and Emissions(kt) of Uruguay?
Give a very brief answer. -4367.4. In the year 1981, what is the difference between the Emissions(kt) of Romania and Emissions(kt) of Uruguay?
Offer a terse response. 1.93e+05. In the year 1982, what is the difference between the Emissions(kt) of Bhutan and Emissions(kt) of Botswana?
Ensure brevity in your answer.  -1067.1. In the year 1982, what is the difference between the Emissions(kt) of Bhutan and Emissions(kt) of Romania?
Provide a short and direct response. -1.96e+05. In the year 1982, what is the difference between the Emissions(kt) of Bhutan and Emissions(kt) of Uruguay?
Give a very brief answer. -4840.44. In the year 1982, what is the difference between the Emissions(kt) of Botswana and Emissions(kt) of Romania?
Your answer should be very brief. -1.95e+05. In the year 1982, what is the difference between the Emissions(kt) in Botswana and Emissions(kt) in Uruguay?
Provide a succinct answer. -3773.34. In the year 1982, what is the difference between the Emissions(kt) in Romania and Emissions(kt) in Uruguay?
Provide a short and direct response. 1.91e+05. In the year 1983, what is the difference between the Emissions(kt) of Bhutan and Emissions(kt) of Botswana?
Make the answer very short. -1001.09. In the year 1983, what is the difference between the Emissions(kt) of Bhutan and Emissions(kt) of Romania?
Provide a short and direct response. -2.01e+05. In the year 1983, what is the difference between the Emissions(kt) of Bhutan and Emissions(kt) of Uruguay?
Keep it short and to the point. -3788.01. In the year 1983, what is the difference between the Emissions(kt) of Botswana and Emissions(kt) of Romania?
Your answer should be compact. -2.00e+05. In the year 1983, what is the difference between the Emissions(kt) in Botswana and Emissions(kt) in Uruguay?
Provide a short and direct response. -2786.92. In the year 1983, what is the difference between the Emissions(kt) of Romania and Emissions(kt) of Uruguay?
Provide a succinct answer. 1.97e+05. In the year 1984, what is the difference between the Emissions(kt) of Bhutan and Emissions(kt) of Botswana?
Make the answer very short. -993.76. In the year 1984, what is the difference between the Emissions(kt) in Bhutan and Emissions(kt) in Romania?
Make the answer very short. -1.89e+05. In the year 1984, what is the difference between the Emissions(kt) of Bhutan and Emissions(kt) of Uruguay?
Keep it short and to the point. -3399.31. In the year 1984, what is the difference between the Emissions(kt) in Botswana and Emissions(kt) in Romania?
Offer a very short reply. -1.88e+05. In the year 1984, what is the difference between the Emissions(kt) of Botswana and Emissions(kt) of Uruguay?
Your answer should be very brief. -2405.55. In the year 1984, what is the difference between the Emissions(kt) of Romania and Emissions(kt) of Uruguay?
Make the answer very short. 1.86e+05. In the year 1985, what is the difference between the Emissions(kt) in Bhutan and Emissions(kt) in Botswana?
Ensure brevity in your answer.  -1096.43. In the year 1985, what is the difference between the Emissions(kt) of Bhutan and Emissions(kt) of Romania?
Your answer should be compact. -1.94e+05. In the year 1985, what is the difference between the Emissions(kt) in Bhutan and Emissions(kt) in Uruguay?
Make the answer very short. -3234.29. In the year 1985, what is the difference between the Emissions(kt) of Botswana and Emissions(kt) of Romania?
Ensure brevity in your answer.  -1.93e+05. In the year 1985, what is the difference between the Emissions(kt) of Botswana and Emissions(kt) of Uruguay?
Provide a short and direct response. -2137.86. In the year 1985, what is the difference between the Emissions(kt) in Romania and Emissions(kt) in Uruguay?
Give a very brief answer. 1.91e+05. What is the ratio of the Emissions(kt) of Bhutan in 1978 to that in 1979?
Your answer should be very brief. 0.5. What is the ratio of the Emissions(kt) of Botswana in 1978 to that in 1979?
Ensure brevity in your answer.  0.88. What is the ratio of the Emissions(kt) in Romania in 1978 to that in 1979?
Your answer should be very brief. 0.99. What is the ratio of the Emissions(kt) of Uruguay in 1978 to that in 1979?
Offer a very short reply. 0.91. What is the ratio of the Emissions(kt) of Bhutan in 1978 to that in 1980?
Ensure brevity in your answer.  0.5. What is the ratio of the Emissions(kt) of Botswana in 1978 to that in 1980?
Offer a terse response. 0.84. What is the ratio of the Emissions(kt) in Romania in 1978 to that in 1980?
Give a very brief answer. 0.99. What is the ratio of the Emissions(kt) in Uruguay in 1978 to that in 1980?
Make the answer very short. 0.98. What is the ratio of the Emissions(kt) in Bhutan in 1978 to that in 1981?
Make the answer very short. 0.43. What is the ratio of the Emissions(kt) of Botswana in 1978 to that in 1981?
Provide a short and direct response. 0.83. What is the ratio of the Emissions(kt) in Romania in 1978 to that in 1981?
Your response must be concise. 0.98. What is the ratio of the Emissions(kt) of Uruguay in 1978 to that in 1981?
Offer a terse response. 1.07. What is the ratio of the Emissions(kt) of Bhutan in 1978 to that in 1982?
Offer a terse response. 0.33. What is the ratio of the Emissions(kt) in Botswana in 1978 to that in 1982?
Offer a terse response. 0.76. What is the ratio of the Emissions(kt) of Uruguay in 1978 to that in 1982?
Provide a short and direct response. 1.18. What is the ratio of the Emissions(kt) of Bhutan in 1978 to that in 1983?
Your answer should be very brief. 0.38. What is the ratio of the Emissions(kt) in Botswana in 1978 to that in 1983?
Provide a short and direct response. 0.81. What is the ratio of the Emissions(kt) of Romania in 1978 to that in 1983?
Your answer should be very brief. 0.97. What is the ratio of the Emissions(kt) of Uruguay in 1978 to that in 1983?
Offer a very short reply. 1.5. What is the ratio of the Emissions(kt) of Bhutan in 1978 to that in 1984?
Ensure brevity in your answer.  0.21. What is the ratio of the Emissions(kt) of Botswana in 1978 to that in 1984?
Your response must be concise. 0.8. What is the ratio of the Emissions(kt) in Romania in 1978 to that in 1984?
Your answer should be compact. 1.02. What is the ratio of the Emissions(kt) in Uruguay in 1978 to that in 1984?
Ensure brevity in your answer.  1.66. What is the ratio of the Emissions(kt) of Bhutan in 1978 to that in 1985?
Keep it short and to the point. 0.18. What is the ratio of the Emissions(kt) in Botswana in 1978 to that in 1985?
Offer a very short reply. 0.72. What is the ratio of the Emissions(kt) in Romania in 1978 to that in 1985?
Your answer should be very brief. 1. What is the ratio of the Emissions(kt) in Uruguay in 1978 to that in 1985?
Your answer should be compact. 1.74. What is the ratio of the Emissions(kt) of Bhutan in 1979 to that in 1980?
Ensure brevity in your answer.  1. What is the ratio of the Emissions(kt) in Botswana in 1979 to that in 1980?
Provide a short and direct response. 0.96. What is the ratio of the Emissions(kt) of Romania in 1979 to that in 1980?
Your answer should be very brief. 1. What is the ratio of the Emissions(kt) in Uruguay in 1979 to that in 1980?
Give a very brief answer. 1.08. What is the ratio of the Emissions(kt) in Bhutan in 1979 to that in 1981?
Provide a succinct answer. 0.86. What is the ratio of the Emissions(kt) in Botswana in 1979 to that in 1981?
Your answer should be compact. 0.93. What is the ratio of the Emissions(kt) in Uruguay in 1979 to that in 1981?
Provide a succinct answer. 1.17. What is the ratio of the Emissions(kt) in Botswana in 1979 to that in 1982?
Offer a very short reply. 0.86. What is the ratio of the Emissions(kt) in Romania in 1979 to that in 1982?
Offer a very short reply. 1. What is the ratio of the Emissions(kt) in Uruguay in 1979 to that in 1982?
Make the answer very short. 1.29. What is the ratio of the Emissions(kt) of Bhutan in 1979 to that in 1983?
Provide a succinct answer. 0.75. What is the ratio of the Emissions(kt) of Botswana in 1979 to that in 1983?
Make the answer very short. 0.91. What is the ratio of the Emissions(kt) in Romania in 1979 to that in 1983?
Your response must be concise. 0.98. What is the ratio of the Emissions(kt) in Uruguay in 1979 to that in 1983?
Make the answer very short. 1.64. What is the ratio of the Emissions(kt) in Bhutan in 1979 to that in 1984?
Your answer should be very brief. 0.43. What is the ratio of the Emissions(kt) in Botswana in 1979 to that in 1984?
Provide a succinct answer. 0.9. What is the ratio of the Emissions(kt) in Romania in 1979 to that in 1984?
Your answer should be compact. 1.04. What is the ratio of the Emissions(kt) of Uruguay in 1979 to that in 1984?
Your answer should be very brief. 1.82. What is the ratio of the Emissions(kt) in Bhutan in 1979 to that in 1985?
Offer a terse response. 0.35. What is the ratio of the Emissions(kt) of Botswana in 1979 to that in 1985?
Offer a very short reply. 0.81. What is the ratio of the Emissions(kt) of Romania in 1979 to that in 1985?
Keep it short and to the point. 1.01. What is the ratio of the Emissions(kt) of Uruguay in 1979 to that in 1985?
Provide a short and direct response. 1.9. What is the ratio of the Emissions(kt) in Bhutan in 1980 to that in 1981?
Ensure brevity in your answer.  0.86. What is the ratio of the Emissions(kt) in Botswana in 1980 to that in 1981?
Your answer should be very brief. 0.98. What is the ratio of the Emissions(kt) in Uruguay in 1980 to that in 1981?
Ensure brevity in your answer.  1.09. What is the ratio of the Emissions(kt) in Botswana in 1980 to that in 1982?
Keep it short and to the point. 0.9. What is the ratio of the Emissions(kt) in Romania in 1980 to that in 1982?
Ensure brevity in your answer.  1. What is the ratio of the Emissions(kt) of Uruguay in 1980 to that in 1982?
Provide a succinct answer. 1.2. What is the ratio of the Emissions(kt) of Bhutan in 1980 to that in 1983?
Your answer should be very brief. 0.75. What is the ratio of the Emissions(kt) of Botswana in 1980 to that in 1983?
Make the answer very short. 0.96. What is the ratio of the Emissions(kt) of Romania in 1980 to that in 1983?
Offer a terse response. 0.98. What is the ratio of the Emissions(kt) of Uruguay in 1980 to that in 1983?
Your response must be concise. 1.53. What is the ratio of the Emissions(kt) in Bhutan in 1980 to that in 1984?
Your answer should be very brief. 0.43. What is the ratio of the Emissions(kt) in Botswana in 1980 to that in 1984?
Offer a very short reply. 0.94. What is the ratio of the Emissions(kt) of Romania in 1980 to that in 1984?
Offer a terse response. 1.04. What is the ratio of the Emissions(kt) of Uruguay in 1980 to that in 1984?
Offer a very short reply. 1.69. What is the ratio of the Emissions(kt) of Bhutan in 1980 to that in 1985?
Offer a very short reply. 0.35. What is the ratio of the Emissions(kt) in Botswana in 1980 to that in 1985?
Give a very brief answer. 0.85. What is the ratio of the Emissions(kt) in Romania in 1980 to that in 1985?
Offer a very short reply. 1.01. What is the ratio of the Emissions(kt) of Uruguay in 1980 to that in 1985?
Ensure brevity in your answer.  1.77. What is the ratio of the Emissions(kt) in Bhutan in 1981 to that in 1982?
Provide a succinct answer. 0.78. What is the ratio of the Emissions(kt) in Botswana in 1981 to that in 1982?
Offer a terse response. 0.92. What is the ratio of the Emissions(kt) of Romania in 1981 to that in 1982?
Offer a terse response. 1.01. What is the ratio of the Emissions(kt) of Uruguay in 1981 to that in 1982?
Offer a very short reply. 1.1. What is the ratio of the Emissions(kt) in Botswana in 1981 to that in 1983?
Offer a very short reply. 0.98. What is the ratio of the Emissions(kt) in Romania in 1981 to that in 1983?
Make the answer very short. 0.99. What is the ratio of the Emissions(kt) of Uruguay in 1981 to that in 1983?
Your answer should be very brief. 1.41. What is the ratio of the Emissions(kt) of Botswana in 1981 to that in 1984?
Offer a terse response. 0.96. What is the ratio of the Emissions(kt) of Romania in 1981 to that in 1984?
Your answer should be compact. 1.05. What is the ratio of the Emissions(kt) of Uruguay in 1981 to that in 1984?
Keep it short and to the point. 1.56. What is the ratio of the Emissions(kt) of Bhutan in 1981 to that in 1985?
Offer a very short reply. 0.41. What is the ratio of the Emissions(kt) of Botswana in 1981 to that in 1985?
Provide a short and direct response. 0.87. What is the ratio of the Emissions(kt) in Romania in 1981 to that in 1985?
Your answer should be very brief. 1.02. What is the ratio of the Emissions(kt) in Uruguay in 1981 to that in 1985?
Ensure brevity in your answer.  1.63. What is the ratio of the Emissions(kt) of Botswana in 1982 to that in 1983?
Keep it short and to the point. 1.07. What is the ratio of the Emissions(kt) in Romania in 1982 to that in 1983?
Ensure brevity in your answer.  0.98. What is the ratio of the Emissions(kt) in Uruguay in 1982 to that in 1983?
Your response must be concise. 1.28. What is the ratio of the Emissions(kt) of Bhutan in 1982 to that in 1984?
Your answer should be compact. 0.64. What is the ratio of the Emissions(kt) in Botswana in 1982 to that in 1984?
Provide a short and direct response. 1.05. What is the ratio of the Emissions(kt) of Romania in 1982 to that in 1984?
Your answer should be very brief. 1.03. What is the ratio of the Emissions(kt) in Uruguay in 1982 to that in 1984?
Keep it short and to the point. 1.41. What is the ratio of the Emissions(kt) of Bhutan in 1982 to that in 1985?
Provide a succinct answer. 0.53. What is the ratio of the Emissions(kt) in Botswana in 1982 to that in 1985?
Your response must be concise. 0.95. What is the ratio of the Emissions(kt) in Romania in 1982 to that in 1985?
Your answer should be compact. 1.01. What is the ratio of the Emissions(kt) of Uruguay in 1982 to that in 1985?
Your answer should be very brief. 1.48. What is the ratio of the Emissions(kt) in Bhutan in 1983 to that in 1984?
Provide a short and direct response. 0.57. What is the ratio of the Emissions(kt) of Botswana in 1983 to that in 1984?
Your answer should be very brief. 0.99. What is the ratio of the Emissions(kt) of Romania in 1983 to that in 1984?
Keep it short and to the point. 1.06. What is the ratio of the Emissions(kt) of Uruguay in 1983 to that in 1984?
Make the answer very short. 1.11. What is the ratio of the Emissions(kt) of Bhutan in 1983 to that in 1985?
Give a very brief answer. 0.47. What is the ratio of the Emissions(kt) in Botswana in 1983 to that in 1985?
Offer a very short reply. 0.89. What is the ratio of the Emissions(kt) of Romania in 1983 to that in 1985?
Offer a very short reply. 1.03. What is the ratio of the Emissions(kt) of Uruguay in 1983 to that in 1985?
Make the answer very short. 1.16. What is the ratio of the Emissions(kt) of Bhutan in 1984 to that in 1985?
Give a very brief answer. 0.82. What is the ratio of the Emissions(kt) of Botswana in 1984 to that in 1985?
Provide a short and direct response. 0.9. What is the ratio of the Emissions(kt) in Romania in 1984 to that in 1985?
Your answer should be very brief. 0.97. What is the ratio of the Emissions(kt) of Uruguay in 1984 to that in 1985?
Your answer should be very brief. 1.05. What is the difference between the highest and the second highest Emissions(kt) in Bhutan?
Give a very brief answer. 11. What is the difference between the highest and the second highest Emissions(kt) in Botswana?
Your answer should be compact. 58.67. What is the difference between the highest and the second highest Emissions(kt) in Romania?
Provide a succinct answer. 2409.22. What is the difference between the highest and the second highest Emissions(kt) in Uruguay?
Your answer should be very brief. 440.04. What is the difference between the highest and the lowest Emissions(kt) in Bhutan?
Keep it short and to the point. 51.34. What is the difference between the highest and the lowest Emissions(kt) of Botswana?
Provide a short and direct response. 326.36. What is the difference between the highest and the lowest Emissions(kt) of Romania?
Offer a terse response. 1.13e+04. What is the difference between the highest and the lowest Emissions(kt) in Uruguay?
Ensure brevity in your answer.  2981.27. 